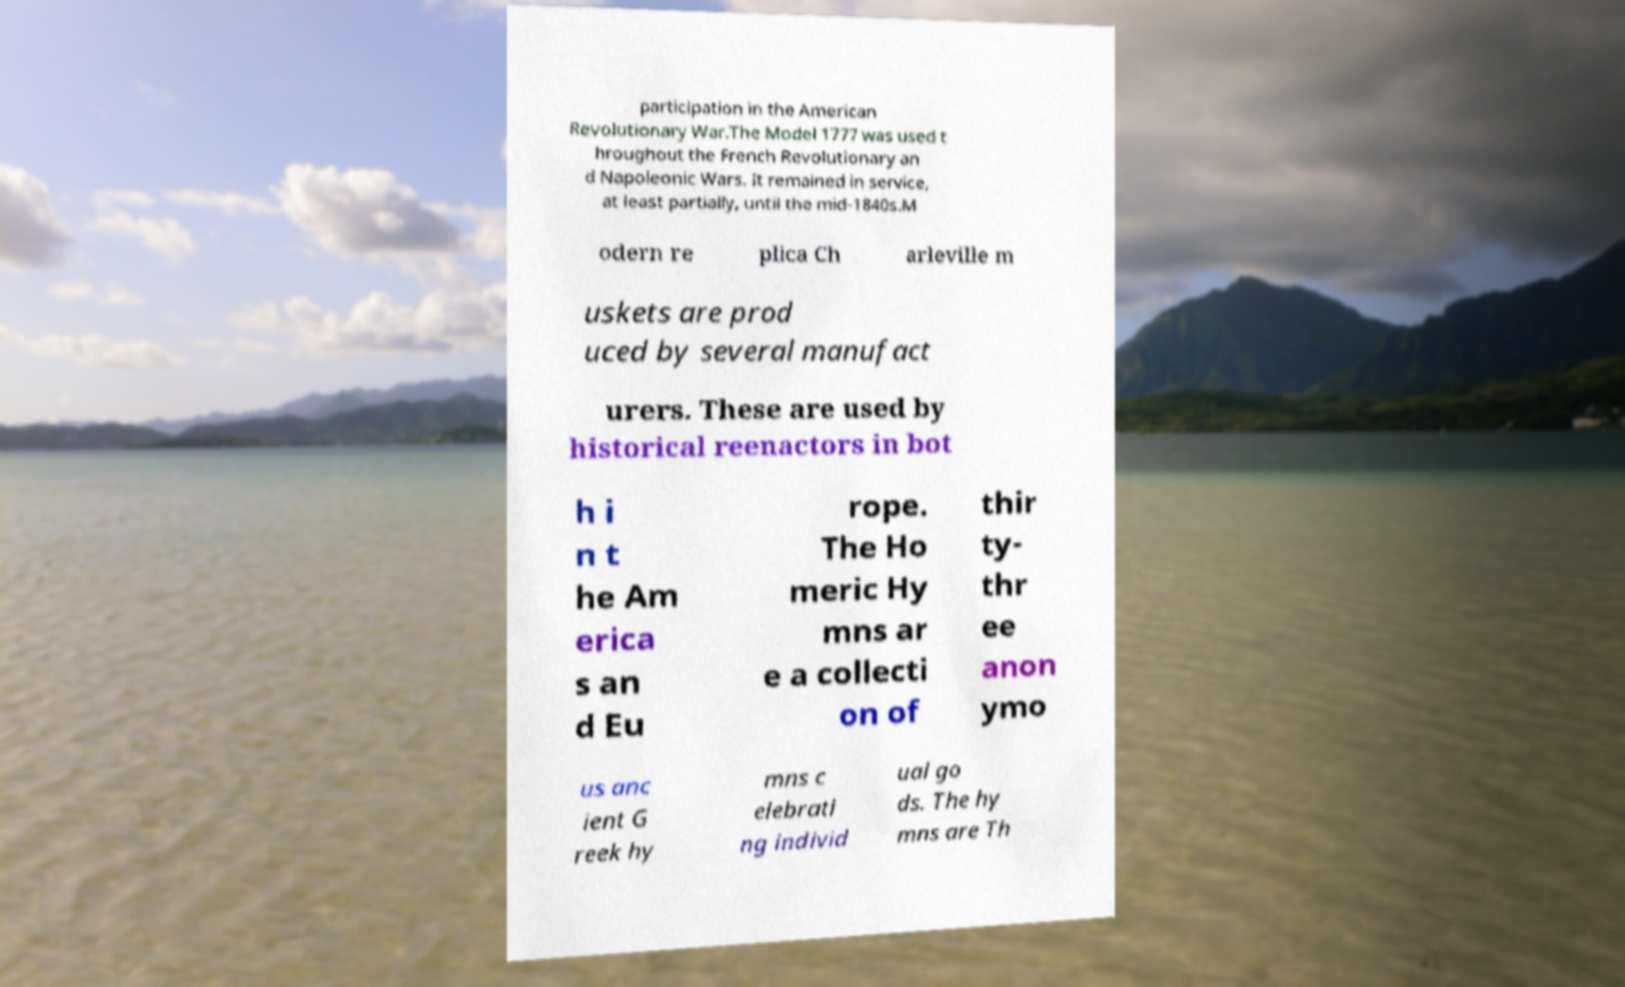Can you read and provide the text displayed in the image?This photo seems to have some interesting text. Can you extract and type it out for me? participation in the American Revolutionary War.The Model 1777 was used t hroughout the French Revolutionary an d Napoleonic Wars. It remained in service, at least partially, until the mid-1840s.M odern re plica Ch arleville m uskets are prod uced by several manufact urers. These are used by historical reenactors in bot h i n t he Am erica s an d Eu rope. The Ho meric Hy mns ar e a collecti on of thir ty- thr ee anon ymo us anc ient G reek hy mns c elebrati ng individ ual go ds. The hy mns are Th 